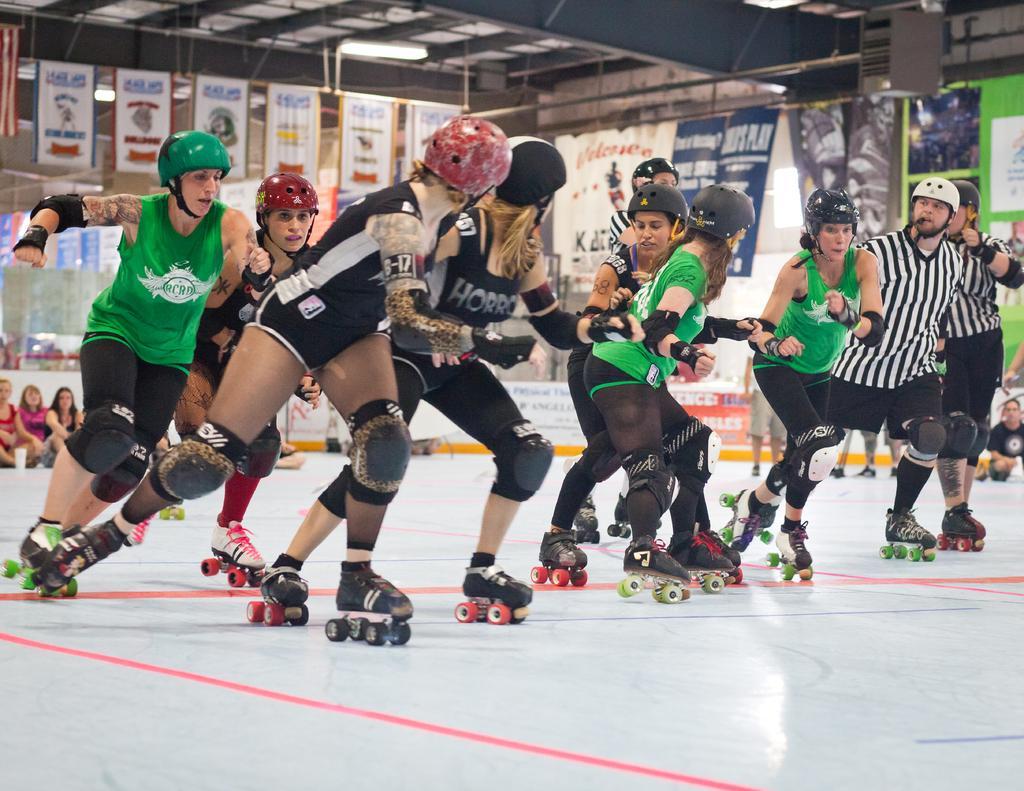In one or two sentences, can you explain what this image depicts? In this image, we can see some people doing the skate boats, in the background there are some people sitting on the floor and we can see some posters. 